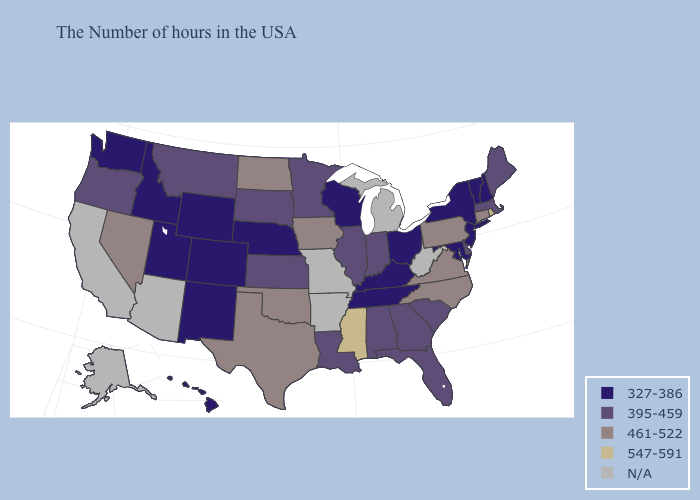Does the first symbol in the legend represent the smallest category?
Keep it brief. Yes. What is the value of North Dakota?
Be succinct. 461-522. What is the value of California?
Write a very short answer. N/A. Name the states that have a value in the range 461-522?
Be succinct. Connecticut, Pennsylvania, Virginia, North Carolina, Iowa, Oklahoma, Texas, North Dakota, Nevada. Among the states that border Vermont , does Massachusetts have the lowest value?
Be succinct. No. Does Vermont have the lowest value in the Northeast?
Concise answer only. Yes. Among the states that border Kentucky , which have the lowest value?
Answer briefly. Ohio, Tennessee. What is the value of Mississippi?
Be succinct. 547-591. Among the states that border Oklahoma , does Kansas have the lowest value?
Quick response, please. No. Name the states that have a value in the range 327-386?
Answer briefly. New Hampshire, Vermont, New York, New Jersey, Maryland, Ohio, Kentucky, Tennessee, Wisconsin, Nebraska, Wyoming, Colorado, New Mexico, Utah, Idaho, Washington, Hawaii. What is the value of Kansas?
Give a very brief answer. 395-459. Among the states that border Georgia , does Tennessee have the lowest value?
Be succinct. Yes. What is the highest value in states that border New Jersey?
Give a very brief answer. 461-522. What is the highest value in the USA?
Short answer required. 547-591. 